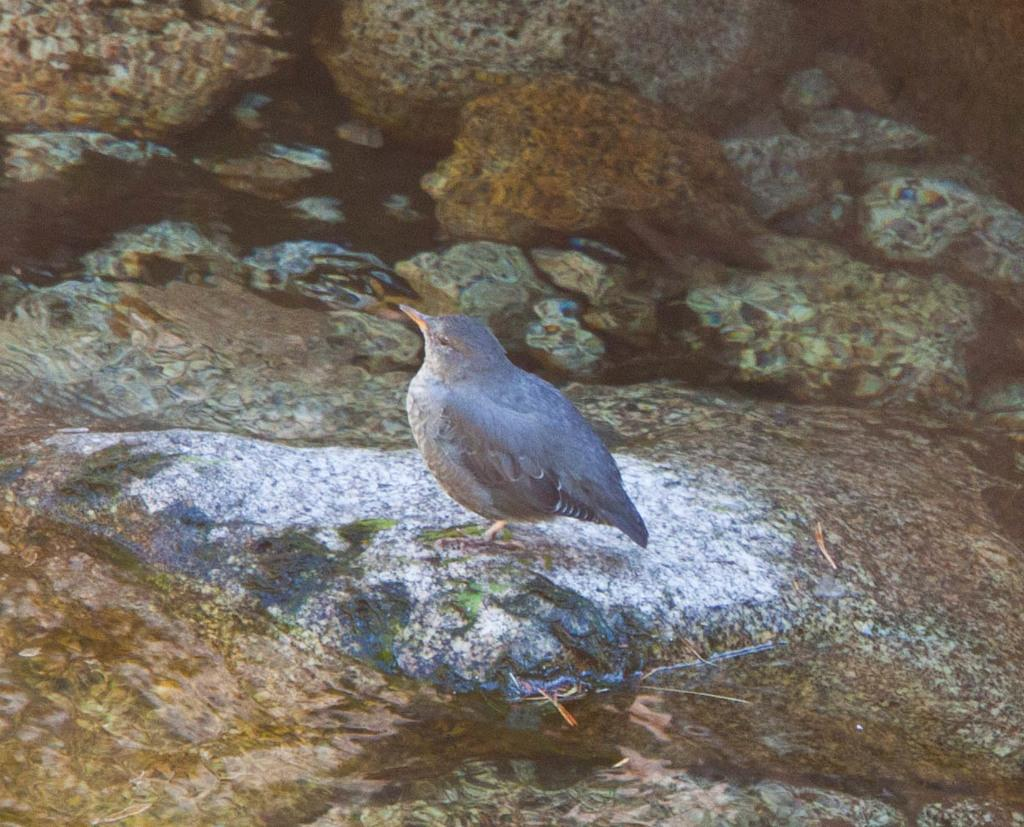What is the main subject of the painting in the image? The painting depicts a bird. Are there any other elements in the painting besides the bird? Yes, the painting also includes rocks. What type of bead is hanging from the bird's beak in the painting? There is no bead hanging from the bird's beak in the painting in the painting; it only depicts a bird and rocks. 